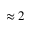<formula> <loc_0><loc_0><loc_500><loc_500>\approx 2</formula> 